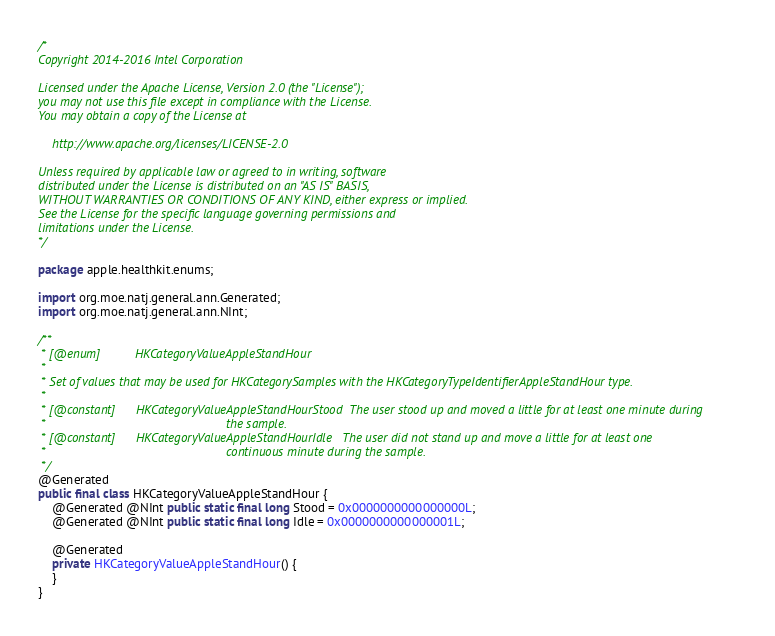Convert code to text. <code><loc_0><loc_0><loc_500><loc_500><_Java_>/*
Copyright 2014-2016 Intel Corporation

Licensed under the Apache License, Version 2.0 (the "License");
you may not use this file except in compliance with the License.
You may obtain a copy of the License at

    http://www.apache.org/licenses/LICENSE-2.0

Unless required by applicable law or agreed to in writing, software
distributed under the License is distributed on an "AS IS" BASIS,
WITHOUT WARRANTIES OR CONDITIONS OF ANY KIND, either express or implied.
See the License for the specific language governing permissions and
limitations under the License.
*/

package apple.healthkit.enums;

import org.moe.natj.general.ann.Generated;
import org.moe.natj.general.ann.NInt;

/**
 * [@enum]          HKCategoryValueAppleStandHour
 * 
 * Set of values that may be used for HKCategorySamples with the HKCategoryTypeIdentifierAppleStandHour type.
 * 
 * [@constant]      HKCategoryValueAppleStandHourStood  The user stood up and moved a little for at least one minute during
 *                                                    the sample.
 * [@constant]      HKCategoryValueAppleStandHourIdle   The user did not stand up and move a little for at least one
 *                                                    continuous minute during the sample.
 */
@Generated
public final class HKCategoryValueAppleStandHour {
    @Generated @NInt public static final long Stood = 0x0000000000000000L;
    @Generated @NInt public static final long Idle = 0x0000000000000001L;

    @Generated
    private HKCategoryValueAppleStandHour() {
    }
}
</code> 